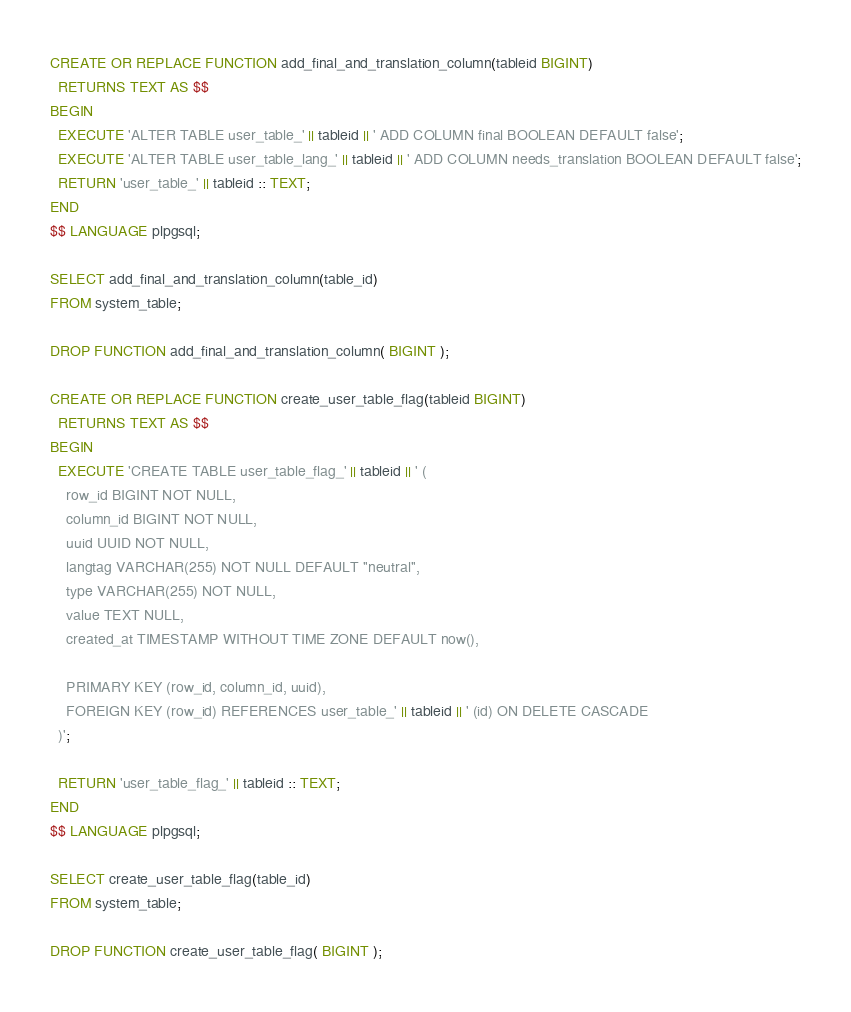<code> <loc_0><loc_0><loc_500><loc_500><_SQL_>CREATE OR REPLACE FUNCTION add_final_and_translation_column(tableid BIGINT)
  RETURNS TEXT AS $$
BEGIN
  EXECUTE 'ALTER TABLE user_table_' || tableid || ' ADD COLUMN final BOOLEAN DEFAULT false';
  EXECUTE 'ALTER TABLE user_table_lang_' || tableid || ' ADD COLUMN needs_translation BOOLEAN DEFAULT false';
  RETURN 'user_table_' || tableid :: TEXT;
END
$$ LANGUAGE plpgsql;

SELECT add_final_and_translation_column(table_id)
FROM system_table;

DROP FUNCTION add_final_and_translation_column( BIGINT );

CREATE OR REPLACE FUNCTION create_user_table_flag(tableid BIGINT)
  RETURNS TEXT AS $$
BEGIN
  EXECUTE 'CREATE TABLE user_table_flag_' || tableid || ' (
    row_id BIGINT NOT NULL,
    column_id BIGINT NOT NULL,
    uuid UUID NOT NULL,
    langtag VARCHAR(255) NOT NULL DEFAULT ''neutral'',
    type VARCHAR(255) NOT NULL,
    value TEXT NULL,
    created_at TIMESTAMP WITHOUT TIME ZONE DEFAULT now(),

    PRIMARY KEY (row_id, column_id, uuid),
    FOREIGN KEY (row_id) REFERENCES user_table_' || tableid || ' (id) ON DELETE CASCADE
  )';

  RETURN 'user_table_flag_' || tableid :: TEXT;
END
$$ LANGUAGE plpgsql;

SELECT create_user_table_flag(table_id)
FROM system_table;

DROP FUNCTION create_user_table_flag( BIGINT );</code> 